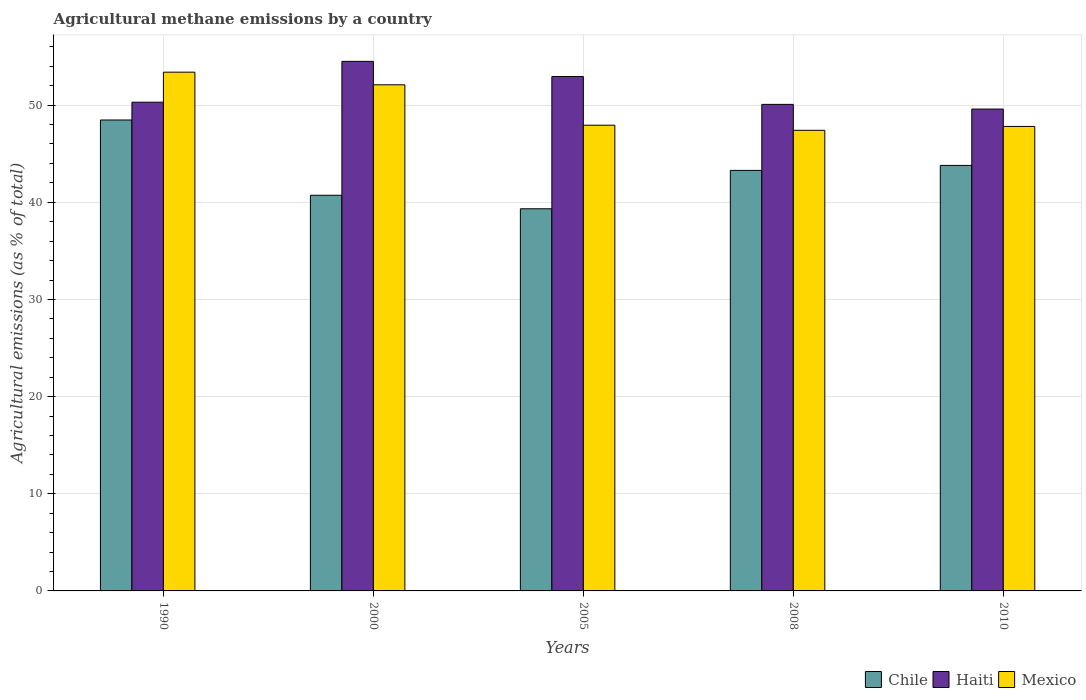How many different coloured bars are there?
Offer a very short reply. 3. What is the label of the 4th group of bars from the left?
Make the answer very short. 2008. What is the amount of agricultural methane emitted in Chile in 2005?
Offer a terse response. 39.33. Across all years, what is the maximum amount of agricultural methane emitted in Chile?
Provide a short and direct response. 48.47. Across all years, what is the minimum amount of agricultural methane emitted in Haiti?
Your answer should be very brief. 49.6. In which year was the amount of agricultural methane emitted in Haiti maximum?
Provide a succinct answer. 2000. In which year was the amount of agricultural methane emitted in Chile minimum?
Provide a succinct answer. 2005. What is the total amount of agricultural methane emitted in Haiti in the graph?
Provide a short and direct response. 257.43. What is the difference between the amount of agricultural methane emitted in Chile in 1990 and that in 2010?
Give a very brief answer. 4.67. What is the difference between the amount of agricultural methane emitted in Mexico in 2008 and the amount of agricultural methane emitted in Chile in 2010?
Offer a terse response. 3.61. What is the average amount of agricultural methane emitted in Chile per year?
Offer a terse response. 43.12. In the year 2010, what is the difference between the amount of agricultural methane emitted in Mexico and amount of agricultural methane emitted in Chile?
Provide a short and direct response. 4.01. In how many years, is the amount of agricultural methane emitted in Haiti greater than 2 %?
Your response must be concise. 5. What is the ratio of the amount of agricultural methane emitted in Haiti in 2000 to that in 2010?
Ensure brevity in your answer.  1.1. Is the difference between the amount of agricultural methane emitted in Mexico in 1990 and 2010 greater than the difference between the amount of agricultural methane emitted in Chile in 1990 and 2010?
Ensure brevity in your answer.  Yes. What is the difference between the highest and the second highest amount of agricultural methane emitted in Mexico?
Provide a succinct answer. 1.3. What is the difference between the highest and the lowest amount of agricultural methane emitted in Chile?
Your answer should be compact. 9.14. In how many years, is the amount of agricultural methane emitted in Haiti greater than the average amount of agricultural methane emitted in Haiti taken over all years?
Offer a terse response. 2. What does the 2nd bar from the left in 2000 represents?
Provide a short and direct response. Haiti. What does the 3rd bar from the right in 2005 represents?
Your response must be concise. Chile. Is it the case that in every year, the sum of the amount of agricultural methane emitted in Haiti and amount of agricultural methane emitted in Chile is greater than the amount of agricultural methane emitted in Mexico?
Offer a terse response. Yes. Are all the bars in the graph horizontal?
Keep it short and to the point. No. How many years are there in the graph?
Give a very brief answer. 5. What is the difference between two consecutive major ticks on the Y-axis?
Provide a short and direct response. 10. Does the graph contain any zero values?
Ensure brevity in your answer.  No. How many legend labels are there?
Keep it short and to the point. 3. How are the legend labels stacked?
Your response must be concise. Horizontal. What is the title of the graph?
Keep it short and to the point. Agricultural methane emissions by a country. Does "Greece" appear as one of the legend labels in the graph?
Your answer should be very brief. No. What is the label or title of the X-axis?
Give a very brief answer. Years. What is the label or title of the Y-axis?
Give a very brief answer. Agricultural emissions (as % of total). What is the Agricultural emissions (as % of total) of Chile in 1990?
Make the answer very short. 48.47. What is the Agricultural emissions (as % of total) in Haiti in 1990?
Give a very brief answer. 50.3. What is the Agricultural emissions (as % of total) in Mexico in 1990?
Offer a terse response. 53.39. What is the Agricultural emissions (as % of total) of Chile in 2000?
Ensure brevity in your answer.  40.72. What is the Agricultural emissions (as % of total) of Haiti in 2000?
Offer a terse response. 54.51. What is the Agricultural emissions (as % of total) in Mexico in 2000?
Give a very brief answer. 52.09. What is the Agricultural emissions (as % of total) of Chile in 2005?
Provide a succinct answer. 39.33. What is the Agricultural emissions (as % of total) of Haiti in 2005?
Your answer should be compact. 52.94. What is the Agricultural emissions (as % of total) of Mexico in 2005?
Offer a very short reply. 47.93. What is the Agricultural emissions (as % of total) of Chile in 2008?
Keep it short and to the point. 43.28. What is the Agricultural emissions (as % of total) in Haiti in 2008?
Your answer should be very brief. 50.08. What is the Agricultural emissions (as % of total) of Mexico in 2008?
Ensure brevity in your answer.  47.41. What is the Agricultural emissions (as % of total) in Chile in 2010?
Keep it short and to the point. 43.8. What is the Agricultural emissions (as % of total) in Haiti in 2010?
Give a very brief answer. 49.6. What is the Agricultural emissions (as % of total) in Mexico in 2010?
Give a very brief answer. 47.81. Across all years, what is the maximum Agricultural emissions (as % of total) in Chile?
Your answer should be compact. 48.47. Across all years, what is the maximum Agricultural emissions (as % of total) in Haiti?
Provide a short and direct response. 54.51. Across all years, what is the maximum Agricultural emissions (as % of total) of Mexico?
Provide a short and direct response. 53.39. Across all years, what is the minimum Agricultural emissions (as % of total) in Chile?
Offer a terse response. 39.33. Across all years, what is the minimum Agricultural emissions (as % of total) of Haiti?
Give a very brief answer. 49.6. Across all years, what is the minimum Agricultural emissions (as % of total) of Mexico?
Provide a succinct answer. 47.41. What is the total Agricultural emissions (as % of total) in Chile in the graph?
Your answer should be compact. 215.6. What is the total Agricultural emissions (as % of total) of Haiti in the graph?
Provide a succinct answer. 257.43. What is the total Agricultural emissions (as % of total) of Mexico in the graph?
Your answer should be very brief. 248.63. What is the difference between the Agricultural emissions (as % of total) in Chile in 1990 and that in 2000?
Your answer should be compact. 7.75. What is the difference between the Agricultural emissions (as % of total) in Haiti in 1990 and that in 2000?
Provide a succinct answer. -4.2. What is the difference between the Agricultural emissions (as % of total) in Mexico in 1990 and that in 2000?
Offer a terse response. 1.3. What is the difference between the Agricultural emissions (as % of total) in Chile in 1990 and that in 2005?
Keep it short and to the point. 9.14. What is the difference between the Agricultural emissions (as % of total) in Haiti in 1990 and that in 2005?
Provide a succinct answer. -2.64. What is the difference between the Agricultural emissions (as % of total) of Mexico in 1990 and that in 2005?
Offer a very short reply. 5.46. What is the difference between the Agricultural emissions (as % of total) of Chile in 1990 and that in 2008?
Ensure brevity in your answer.  5.19. What is the difference between the Agricultural emissions (as % of total) of Haiti in 1990 and that in 2008?
Your answer should be compact. 0.23. What is the difference between the Agricultural emissions (as % of total) in Mexico in 1990 and that in 2008?
Your answer should be very brief. 5.98. What is the difference between the Agricultural emissions (as % of total) of Chile in 1990 and that in 2010?
Your answer should be very brief. 4.67. What is the difference between the Agricultural emissions (as % of total) of Haiti in 1990 and that in 2010?
Your answer should be compact. 0.71. What is the difference between the Agricultural emissions (as % of total) of Mexico in 1990 and that in 2010?
Keep it short and to the point. 5.59. What is the difference between the Agricultural emissions (as % of total) of Chile in 2000 and that in 2005?
Your answer should be compact. 1.39. What is the difference between the Agricultural emissions (as % of total) of Haiti in 2000 and that in 2005?
Provide a succinct answer. 1.56. What is the difference between the Agricultural emissions (as % of total) in Mexico in 2000 and that in 2005?
Your response must be concise. 4.16. What is the difference between the Agricultural emissions (as % of total) of Chile in 2000 and that in 2008?
Provide a short and direct response. -2.56. What is the difference between the Agricultural emissions (as % of total) in Haiti in 2000 and that in 2008?
Give a very brief answer. 4.43. What is the difference between the Agricultural emissions (as % of total) of Mexico in 2000 and that in 2008?
Your response must be concise. 4.68. What is the difference between the Agricultural emissions (as % of total) in Chile in 2000 and that in 2010?
Your answer should be very brief. -3.07. What is the difference between the Agricultural emissions (as % of total) of Haiti in 2000 and that in 2010?
Your answer should be compact. 4.91. What is the difference between the Agricultural emissions (as % of total) in Mexico in 2000 and that in 2010?
Your response must be concise. 4.29. What is the difference between the Agricultural emissions (as % of total) in Chile in 2005 and that in 2008?
Ensure brevity in your answer.  -3.95. What is the difference between the Agricultural emissions (as % of total) in Haiti in 2005 and that in 2008?
Provide a succinct answer. 2.87. What is the difference between the Agricultural emissions (as % of total) in Mexico in 2005 and that in 2008?
Provide a succinct answer. 0.52. What is the difference between the Agricultural emissions (as % of total) of Chile in 2005 and that in 2010?
Your response must be concise. -4.46. What is the difference between the Agricultural emissions (as % of total) in Haiti in 2005 and that in 2010?
Your answer should be very brief. 3.35. What is the difference between the Agricultural emissions (as % of total) in Mexico in 2005 and that in 2010?
Your answer should be very brief. 0.13. What is the difference between the Agricultural emissions (as % of total) of Chile in 2008 and that in 2010?
Keep it short and to the point. -0.51. What is the difference between the Agricultural emissions (as % of total) in Haiti in 2008 and that in 2010?
Your answer should be compact. 0.48. What is the difference between the Agricultural emissions (as % of total) of Mexico in 2008 and that in 2010?
Your answer should be compact. -0.4. What is the difference between the Agricultural emissions (as % of total) in Chile in 1990 and the Agricultural emissions (as % of total) in Haiti in 2000?
Provide a short and direct response. -6.04. What is the difference between the Agricultural emissions (as % of total) in Chile in 1990 and the Agricultural emissions (as % of total) in Mexico in 2000?
Keep it short and to the point. -3.62. What is the difference between the Agricultural emissions (as % of total) in Haiti in 1990 and the Agricultural emissions (as % of total) in Mexico in 2000?
Your answer should be compact. -1.79. What is the difference between the Agricultural emissions (as % of total) of Chile in 1990 and the Agricultural emissions (as % of total) of Haiti in 2005?
Your response must be concise. -4.47. What is the difference between the Agricultural emissions (as % of total) of Chile in 1990 and the Agricultural emissions (as % of total) of Mexico in 2005?
Provide a short and direct response. 0.54. What is the difference between the Agricultural emissions (as % of total) in Haiti in 1990 and the Agricultural emissions (as % of total) in Mexico in 2005?
Your answer should be compact. 2.37. What is the difference between the Agricultural emissions (as % of total) of Chile in 1990 and the Agricultural emissions (as % of total) of Haiti in 2008?
Your answer should be very brief. -1.61. What is the difference between the Agricultural emissions (as % of total) of Chile in 1990 and the Agricultural emissions (as % of total) of Mexico in 2008?
Provide a short and direct response. 1.06. What is the difference between the Agricultural emissions (as % of total) of Haiti in 1990 and the Agricultural emissions (as % of total) of Mexico in 2008?
Give a very brief answer. 2.89. What is the difference between the Agricultural emissions (as % of total) of Chile in 1990 and the Agricultural emissions (as % of total) of Haiti in 2010?
Offer a very short reply. -1.13. What is the difference between the Agricultural emissions (as % of total) in Chile in 1990 and the Agricultural emissions (as % of total) in Mexico in 2010?
Offer a very short reply. 0.66. What is the difference between the Agricultural emissions (as % of total) in Haiti in 1990 and the Agricultural emissions (as % of total) in Mexico in 2010?
Offer a very short reply. 2.5. What is the difference between the Agricultural emissions (as % of total) of Chile in 2000 and the Agricultural emissions (as % of total) of Haiti in 2005?
Provide a short and direct response. -12.22. What is the difference between the Agricultural emissions (as % of total) in Chile in 2000 and the Agricultural emissions (as % of total) in Mexico in 2005?
Provide a short and direct response. -7.21. What is the difference between the Agricultural emissions (as % of total) of Haiti in 2000 and the Agricultural emissions (as % of total) of Mexico in 2005?
Keep it short and to the point. 6.57. What is the difference between the Agricultural emissions (as % of total) of Chile in 2000 and the Agricultural emissions (as % of total) of Haiti in 2008?
Make the answer very short. -9.35. What is the difference between the Agricultural emissions (as % of total) of Chile in 2000 and the Agricultural emissions (as % of total) of Mexico in 2008?
Provide a short and direct response. -6.69. What is the difference between the Agricultural emissions (as % of total) in Haiti in 2000 and the Agricultural emissions (as % of total) in Mexico in 2008?
Provide a succinct answer. 7.1. What is the difference between the Agricultural emissions (as % of total) in Chile in 2000 and the Agricultural emissions (as % of total) in Haiti in 2010?
Offer a very short reply. -8.87. What is the difference between the Agricultural emissions (as % of total) of Chile in 2000 and the Agricultural emissions (as % of total) of Mexico in 2010?
Keep it short and to the point. -7.08. What is the difference between the Agricultural emissions (as % of total) of Haiti in 2000 and the Agricultural emissions (as % of total) of Mexico in 2010?
Ensure brevity in your answer.  6.7. What is the difference between the Agricultural emissions (as % of total) of Chile in 2005 and the Agricultural emissions (as % of total) of Haiti in 2008?
Keep it short and to the point. -10.74. What is the difference between the Agricultural emissions (as % of total) of Chile in 2005 and the Agricultural emissions (as % of total) of Mexico in 2008?
Your answer should be very brief. -8.08. What is the difference between the Agricultural emissions (as % of total) of Haiti in 2005 and the Agricultural emissions (as % of total) of Mexico in 2008?
Your answer should be very brief. 5.54. What is the difference between the Agricultural emissions (as % of total) of Chile in 2005 and the Agricultural emissions (as % of total) of Haiti in 2010?
Make the answer very short. -10.26. What is the difference between the Agricultural emissions (as % of total) in Chile in 2005 and the Agricultural emissions (as % of total) in Mexico in 2010?
Your answer should be compact. -8.47. What is the difference between the Agricultural emissions (as % of total) in Haiti in 2005 and the Agricultural emissions (as % of total) in Mexico in 2010?
Ensure brevity in your answer.  5.14. What is the difference between the Agricultural emissions (as % of total) of Chile in 2008 and the Agricultural emissions (as % of total) of Haiti in 2010?
Offer a terse response. -6.31. What is the difference between the Agricultural emissions (as % of total) in Chile in 2008 and the Agricultural emissions (as % of total) in Mexico in 2010?
Your response must be concise. -4.52. What is the difference between the Agricultural emissions (as % of total) in Haiti in 2008 and the Agricultural emissions (as % of total) in Mexico in 2010?
Your response must be concise. 2.27. What is the average Agricultural emissions (as % of total) in Chile per year?
Offer a terse response. 43.12. What is the average Agricultural emissions (as % of total) of Haiti per year?
Your answer should be compact. 51.49. What is the average Agricultural emissions (as % of total) of Mexico per year?
Offer a very short reply. 49.73. In the year 1990, what is the difference between the Agricultural emissions (as % of total) in Chile and Agricultural emissions (as % of total) in Haiti?
Keep it short and to the point. -1.83. In the year 1990, what is the difference between the Agricultural emissions (as % of total) in Chile and Agricultural emissions (as % of total) in Mexico?
Make the answer very short. -4.92. In the year 1990, what is the difference between the Agricultural emissions (as % of total) of Haiti and Agricultural emissions (as % of total) of Mexico?
Offer a terse response. -3.09. In the year 2000, what is the difference between the Agricultural emissions (as % of total) in Chile and Agricultural emissions (as % of total) in Haiti?
Your response must be concise. -13.78. In the year 2000, what is the difference between the Agricultural emissions (as % of total) in Chile and Agricultural emissions (as % of total) in Mexico?
Your answer should be very brief. -11.37. In the year 2000, what is the difference between the Agricultural emissions (as % of total) of Haiti and Agricultural emissions (as % of total) of Mexico?
Ensure brevity in your answer.  2.41. In the year 2005, what is the difference between the Agricultural emissions (as % of total) of Chile and Agricultural emissions (as % of total) of Haiti?
Offer a very short reply. -13.61. In the year 2005, what is the difference between the Agricultural emissions (as % of total) of Chile and Agricultural emissions (as % of total) of Mexico?
Give a very brief answer. -8.6. In the year 2005, what is the difference between the Agricultural emissions (as % of total) of Haiti and Agricultural emissions (as % of total) of Mexico?
Your answer should be compact. 5.01. In the year 2008, what is the difference between the Agricultural emissions (as % of total) in Chile and Agricultural emissions (as % of total) in Haiti?
Provide a short and direct response. -6.8. In the year 2008, what is the difference between the Agricultural emissions (as % of total) of Chile and Agricultural emissions (as % of total) of Mexico?
Your answer should be very brief. -4.13. In the year 2008, what is the difference between the Agricultural emissions (as % of total) of Haiti and Agricultural emissions (as % of total) of Mexico?
Provide a short and direct response. 2.67. In the year 2010, what is the difference between the Agricultural emissions (as % of total) in Chile and Agricultural emissions (as % of total) in Haiti?
Your answer should be very brief. -5.8. In the year 2010, what is the difference between the Agricultural emissions (as % of total) of Chile and Agricultural emissions (as % of total) of Mexico?
Give a very brief answer. -4.01. In the year 2010, what is the difference between the Agricultural emissions (as % of total) of Haiti and Agricultural emissions (as % of total) of Mexico?
Your response must be concise. 1.79. What is the ratio of the Agricultural emissions (as % of total) of Chile in 1990 to that in 2000?
Offer a very short reply. 1.19. What is the ratio of the Agricultural emissions (as % of total) in Haiti in 1990 to that in 2000?
Your answer should be very brief. 0.92. What is the ratio of the Agricultural emissions (as % of total) of Chile in 1990 to that in 2005?
Give a very brief answer. 1.23. What is the ratio of the Agricultural emissions (as % of total) of Haiti in 1990 to that in 2005?
Provide a short and direct response. 0.95. What is the ratio of the Agricultural emissions (as % of total) of Mexico in 1990 to that in 2005?
Provide a succinct answer. 1.11. What is the ratio of the Agricultural emissions (as % of total) in Chile in 1990 to that in 2008?
Your answer should be compact. 1.12. What is the ratio of the Agricultural emissions (as % of total) of Haiti in 1990 to that in 2008?
Your response must be concise. 1. What is the ratio of the Agricultural emissions (as % of total) of Mexico in 1990 to that in 2008?
Give a very brief answer. 1.13. What is the ratio of the Agricultural emissions (as % of total) of Chile in 1990 to that in 2010?
Make the answer very short. 1.11. What is the ratio of the Agricultural emissions (as % of total) in Haiti in 1990 to that in 2010?
Your response must be concise. 1.01. What is the ratio of the Agricultural emissions (as % of total) of Mexico in 1990 to that in 2010?
Keep it short and to the point. 1.12. What is the ratio of the Agricultural emissions (as % of total) of Chile in 2000 to that in 2005?
Give a very brief answer. 1.04. What is the ratio of the Agricultural emissions (as % of total) of Haiti in 2000 to that in 2005?
Offer a terse response. 1.03. What is the ratio of the Agricultural emissions (as % of total) in Mexico in 2000 to that in 2005?
Give a very brief answer. 1.09. What is the ratio of the Agricultural emissions (as % of total) of Chile in 2000 to that in 2008?
Offer a terse response. 0.94. What is the ratio of the Agricultural emissions (as % of total) in Haiti in 2000 to that in 2008?
Provide a succinct answer. 1.09. What is the ratio of the Agricultural emissions (as % of total) in Mexico in 2000 to that in 2008?
Offer a very short reply. 1.1. What is the ratio of the Agricultural emissions (as % of total) of Chile in 2000 to that in 2010?
Ensure brevity in your answer.  0.93. What is the ratio of the Agricultural emissions (as % of total) in Haiti in 2000 to that in 2010?
Ensure brevity in your answer.  1.1. What is the ratio of the Agricultural emissions (as % of total) in Mexico in 2000 to that in 2010?
Make the answer very short. 1.09. What is the ratio of the Agricultural emissions (as % of total) in Chile in 2005 to that in 2008?
Make the answer very short. 0.91. What is the ratio of the Agricultural emissions (as % of total) in Haiti in 2005 to that in 2008?
Provide a short and direct response. 1.06. What is the ratio of the Agricultural emissions (as % of total) of Mexico in 2005 to that in 2008?
Provide a short and direct response. 1.01. What is the ratio of the Agricultural emissions (as % of total) of Chile in 2005 to that in 2010?
Your answer should be very brief. 0.9. What is the ratio of the Agricultural emissions (as % of total) in Haiti in 2005 to that in 2010?
Keep it short and to the point. 1.07. What is the ratio of the Agricultural emissions (as % of total) in Mexico in 2005 to that in 2010?
Give a very brief answer. 1. What is the ratio of the Agricultural emissions (as % of total) in Chile in 2008 to that in 2010?
Your answer should be very brief. 0.99. What is the ratio of the Agricultural emissions (as % of total) of Haiti in 2008 to that in 2010?
Ensure brevity in your answer.  1.01. What is the ratio of the Agricultural emissions (as % of total) of Mexico in 2008 to that in 2010?
Ensure brevity in your answer.  0.99. What is the difference between the highest and the second highest Agricultural emissions (as % of total) of Chile?
Make the answer very short. 4.67. What is the difference between the highest and the second highest Agricultural emissions (as % of total) in Haiti?
Offer a very short reply. 1.56. What is the difference between the highest and the second highest Agricultural emissions (as % of total) in Mexico?
Your answer should be very brief. 1.3. What is the difference between the highest and the lowest Agricultural emissions (as % of total) of Chile?
Provide a succinct answer. 9.14. What is the difference between the highest and the lowest Agricultural emissions (as % of total) of Haiti?
Provide a short and direct response. 4.91. What is the difference between the highest and the lowest Agricultural emissions (as % of total) of Mexico?
Ensure brevity in your answer.  5.98. 